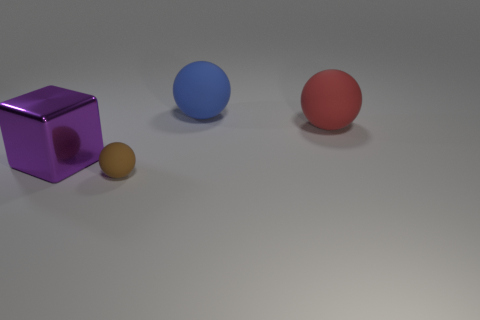Add 4 large purple metallic blocks. How many objects exist? 8 Subtract all blocks. How many objects are left? 3 Add 4 small brown objects. How many small brown objects exist? 5 Subtract 0 brown blocks. How many objects are left? 4 Subtract all big brown cylinders. Subtract all small brown objects. How many objects are left? 3 Add 1 blue balls. How many blue balls are left? 2 